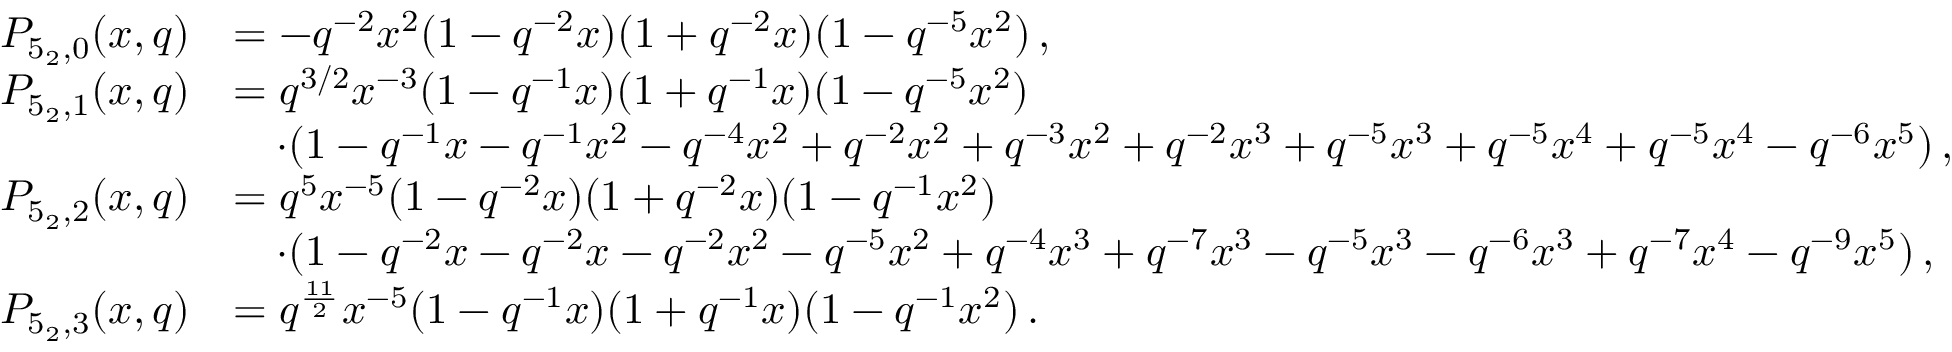Convert formula to latex. <formula><loc_0><loc_0><loc_500><loc_500>\begin{array} { r l } { P _ { 5 _ { 2 } , 0 } ( x , q ) } & { = - q ^ { - 2 } x ^ { 2 } ( 1 - q ^ { - 2 } x ) ( 1 + q ^ { - 2 } x ) ( 1 - q ^ { - 5 } x ^ { 2 } ) \, , } \\ { P _ { 5 _ { 2 } , 1 } ( x , q ) } & { = q ^ { 3 / 2 } x ^ { - 3 } ( 1 - q ^ { - 1 } x ) ( 1 + q ^ { - 1 } x ) ( 1 - q ^ { - 5 } x ^ { 2 } ) } \\ & { \quad \cdot ( 1 - q ^ { - 1 } x - q ^ { - 1 } x ^ { 2 } - q ^ { - 4 } x ^ { 2 } + q ^ { - 2 } x ^ { 2 } + q ^ { - 3 } x ^ { 2 } + q ^ { - 2 } x ^ { 3 } + q ^ { - 5 } x ^ { 3 } + q ^ { - 5 } x ^ { 4 } + q ^ { - 5 } x ^ { 4 } - q ^ { - 6 } x ^ { 5 } ) \, , } \\ { P _ { 5 _ { 2 } , 2 } ( x , q ) } & { = q ^ { 5 } x ^ { - 5 } ( 1 - q ^ { - 2 } x ) ( 1 + q ^ { - 2 } x ) ( 1 - q ^ { - 1 } x ^ { 2 } ) } \\ & { \quad \cdot ( 1 - q ^ { - 2 } x - q ^ { - 2 } x - q ^ { - 2 } x ^ { 2 } - q ^ { - 5 } x ^ { 2 } + q ^ { - 4 } x ^ { 3 } + q ^ { - 7 } x ^ { 3 } - q ^ { - 5 } x ^ { 3 } - q ^ { - 6 } x ^ { 3 } + q ^ { - 7 } x ^ { 4 } - q ^ { - 9 } x ^ { 5 } ) \, , } \\ { P _ { 5 _ { 2 } , 3 } ( x , q ) } & { = q ^ { \frac { 1 1 } { 2 } } x ^ { - 5 } ( 1 - q ^ { - 1 } x ) ( 1 + q ^ { - 1 } x ) ( 1 - q ^ { - 1 } x ^ { 2 } ) \, . } \end{array}</formula> 